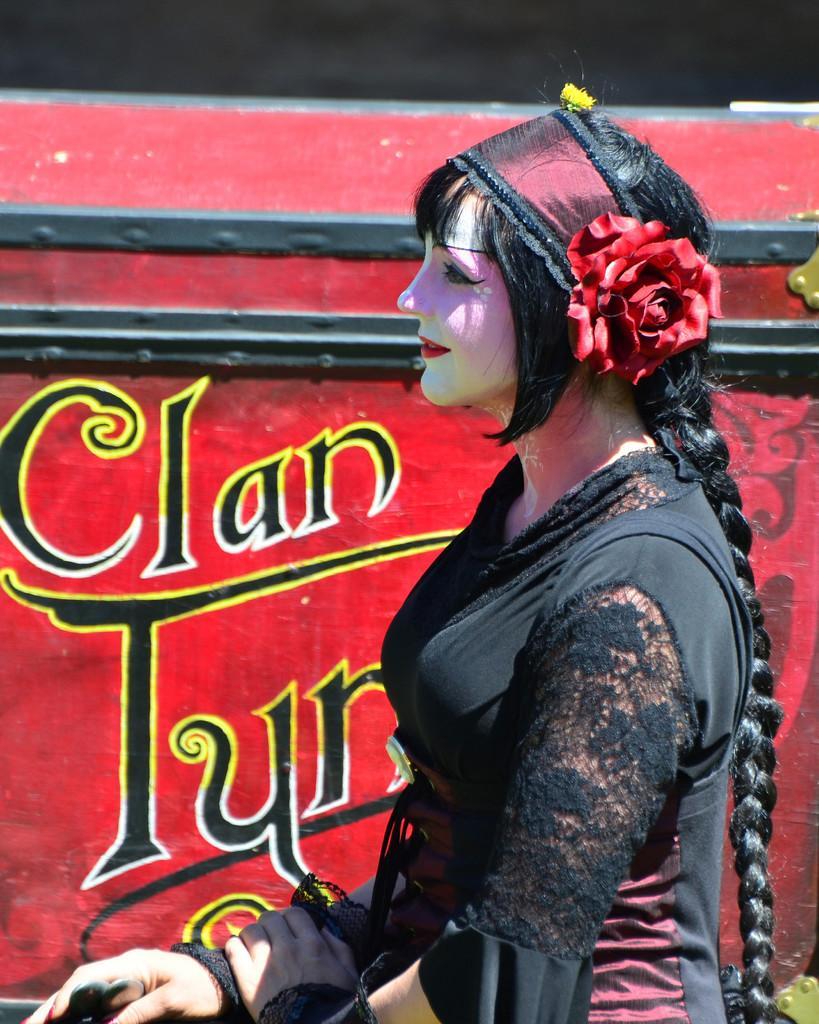Please provide a concise description of this image. There is a lady in the foreground area of the image, it seems like a poster in the background. 